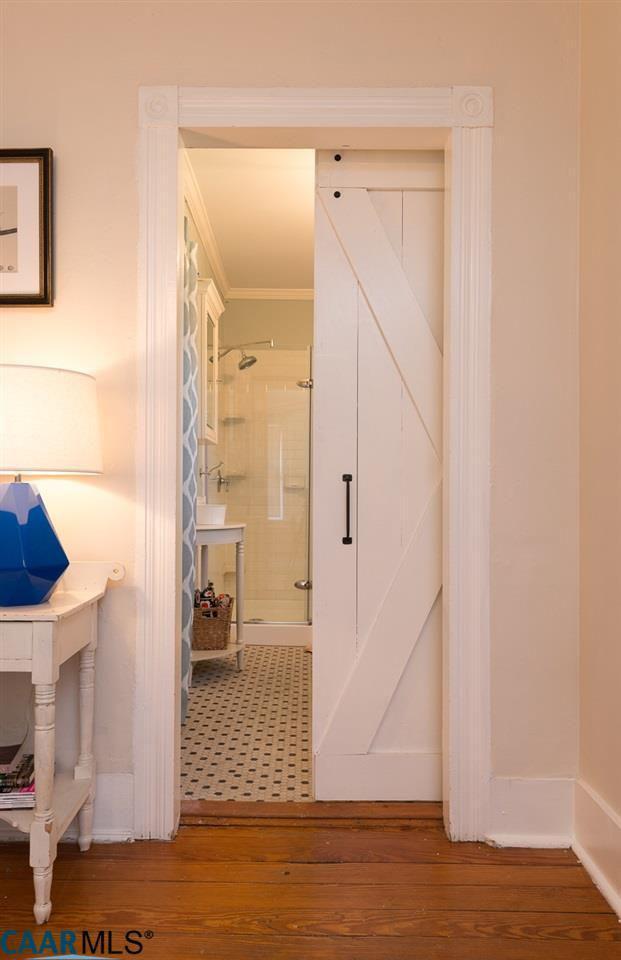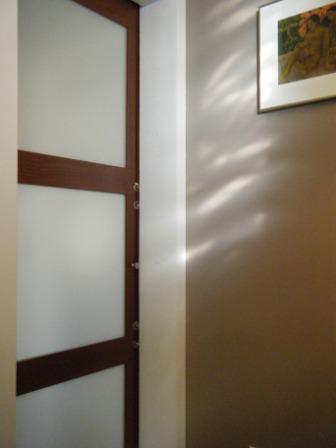The first image is the image on the left, the second image is the image on the right. Analyze the images presented: Is the assertion "One image shows a doorway with a single white door in a head-on view, and the door is half-closed with the left half open." valid? Answer yes or no. Yes. The first image is the image on the left, the second image is the image on the right. Given the left and right images, does the statement "One sliding door is partially open and showing a bathroom behind it." hold true? Answer yes or no. Yes. 